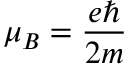<formula> <loc_0><loc_0><loc_500><loc_500>\mu _ { B } = \frac { e } { 2 m }</formula> 